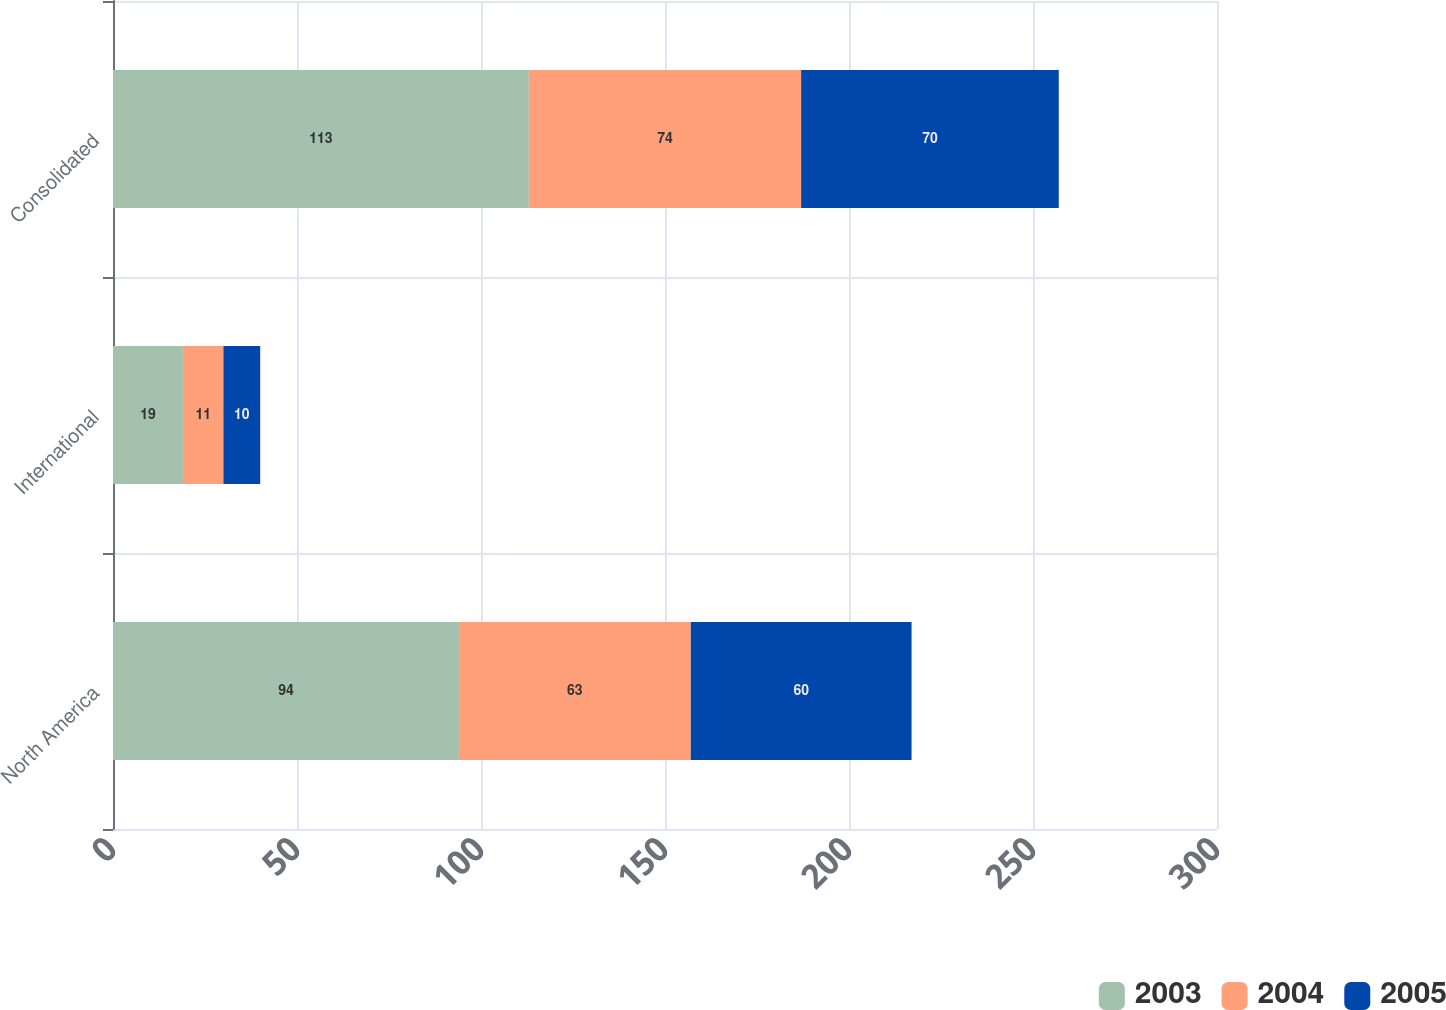Convert chart to OTSL. <chart><loc_0><loc_0><loc_500><loc_500><stacked_bar_chart><ecel><fcel>North America<fcel>International<fcel>Consolidated<nl><fcel>2003<fcel>94<fcel>19<fcel>113<nl><fcel>2004<fcel>63<fcel>11<fcel>74<nl><fcel>2005<fcel>60<fcel>10<fcel>70<nl></chart> 